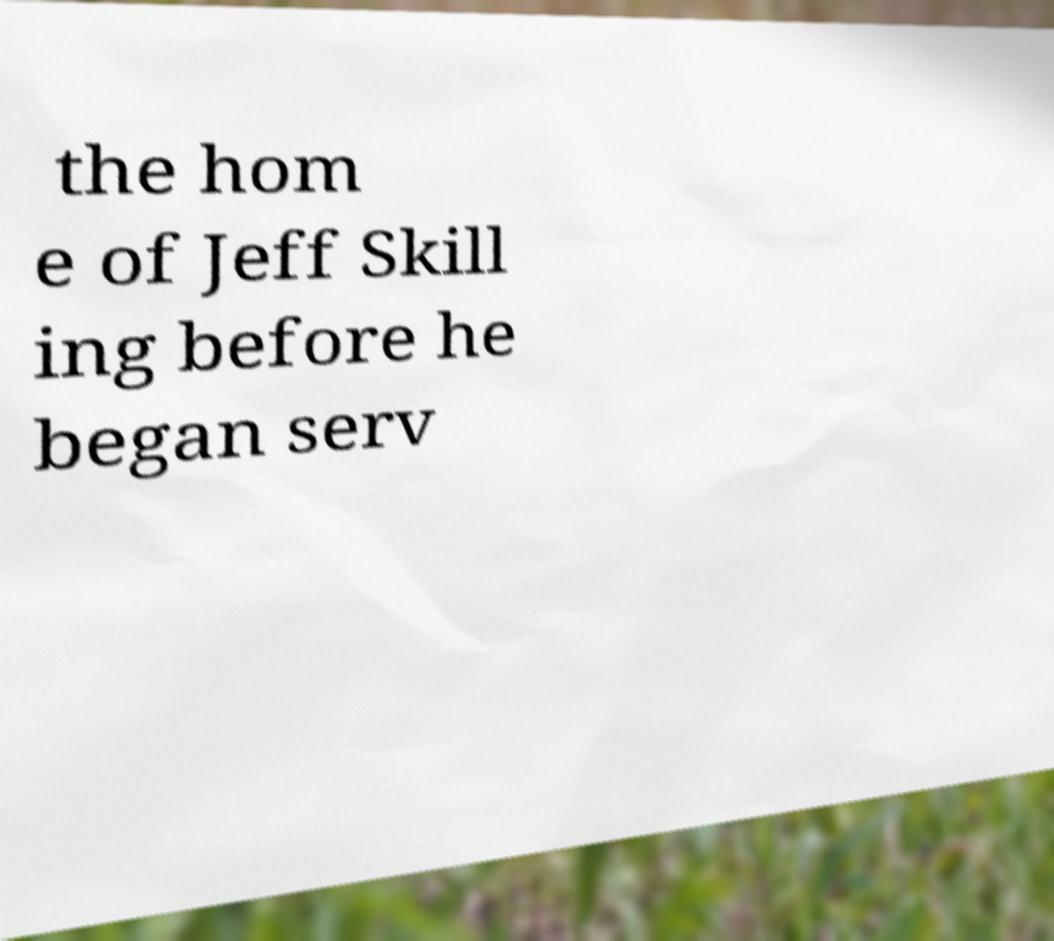Could you assist in decoding the text presented in this image and type it out clearly? the hom e of Jeff Skill ing before he began serv 